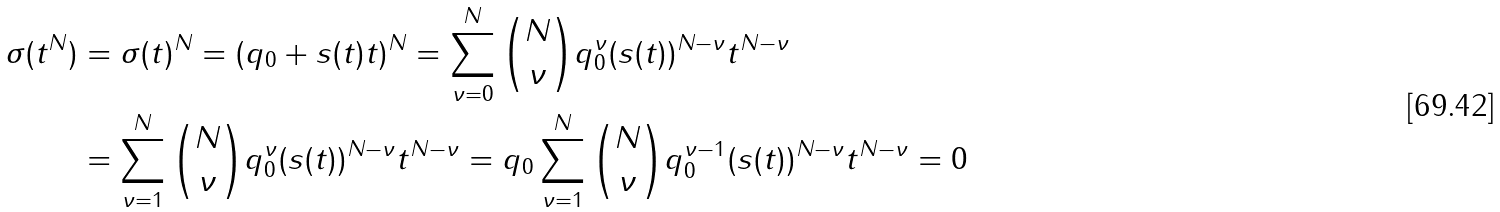Convert formula to latex. <formula><loc_0><loc_0><loc_500><loc_500>\sigma ( t ^ { N } ) & = \sigma ( t ) ^ { N } = ( q _ { 0 } + s ( t ) t ) ^ { N } = \sum _ { \nu = 0 } ^ { N } \binom { N } { \nu } q _ { 0 } ^ { \nu } ( s ( t ) ) ^ { N - \nu } t ^ { N - \nu } \\ & = \sum _ { \nu = 1 } ^ { N } \binom { N } { \nu } q _ { 0 } ^ { \nu } ( s ( t ) ) ^ { N - \nu } t ^ { N - \nu } = q _ { 0 } \sum _ { \nu = 1 } ^ { N } \binom { N } { \nu } q _ { 0 } ^ { \nu - 1 } ( s ( t ) ) ^ { N - \nu } t ^ { N - \nu } = 0</formula> 